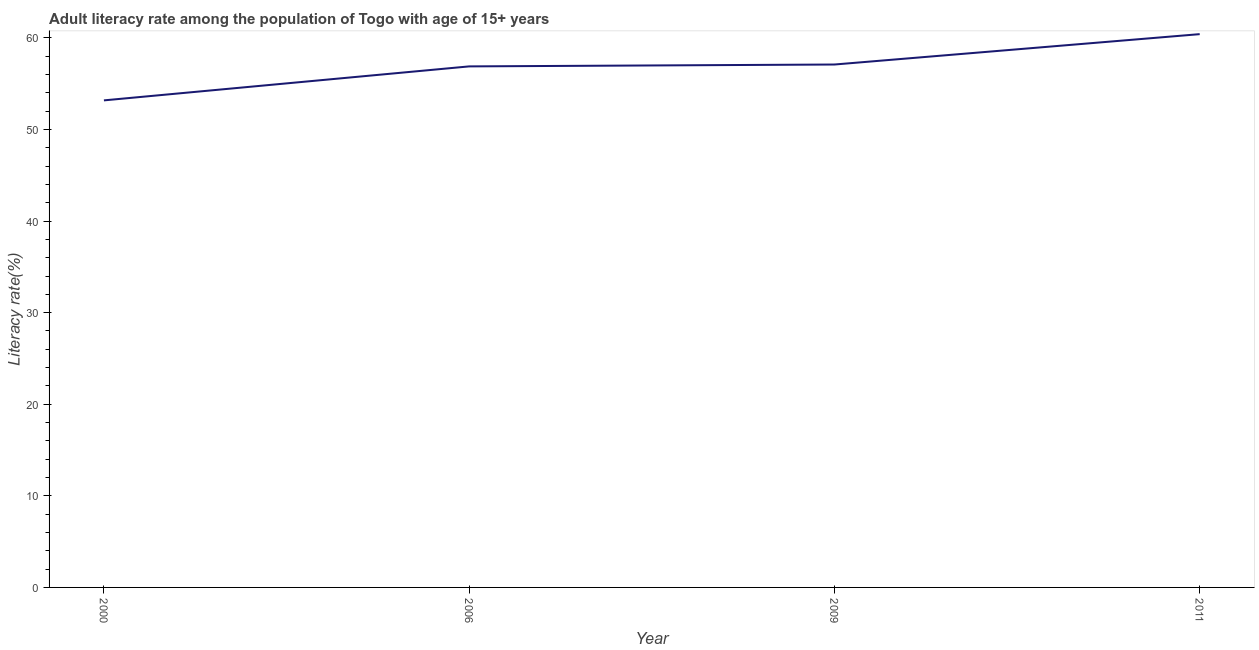What is the adult literacy rate in 2000?
Give a very brief answer. 53.18. Across all years, what is the maximum adult literacy rate?
Offer a terse response. 60.41. Across all years, what is the minimum adult literacy rate?
Provide a short and direct response. 53.18. In which year was the adult literacy rate maximum?
Offer a very short reply. 2011. In which year was the adult literacy rate minimum?
Offer a very short reply. 2000. What is the sum of the adult literacy rate?
Provide a succinct answer. 227.57. What is the difference between the adult literacy rate in 2000 and 2009?
Your answer should be compact. -3.92. What is the average adult literacy rate per year?
Your answer should be compact. 56.89. What is the median adult literacy rate?
Give a very brief answer. 56.99. In how many years, is the adult literacy rate greater than 18 %?
Make the answer very short. 4. Do a majority of the years between 2009 and 2000 (inclusive) have adult literacy rate greater than 42 %?
Provide a succinct answer. No. What is the ratio of the adult literacy rate in 2000 to that in 2011?
Keep it short and to the point. 0.88. What is the difference between the highest and the second highest adult literacy rate?
Make the answer very short. 3.32. What is the difference between the highest and the lowest adult literacy rate?
Offer a very short reply. 7.23. In how many years, is the adult literacy rate greater than the average adult literacy rate taken over all years?
Make the answer very short. 2. How many years are there in the graph?
Your answer should be very brief. 4. Are the values on the major ticks of Y-axis written in scientific E-notation?
Provide a succinct answer. No. What is the title of the graph?
Your response must be concise. Adult literacy rate among the population of Togo with age of 15+ years. What is the label or title of the Y-axis?
Provide a short and direct response. Literacy rate(%). What is the Literacy rate(%) of 2000?
Provide a succinct answer. 53.18. What is the Literacy rate(%) of 2006?
Keep it short and to the point. 56.89. What is the Literacy rate(%) in 2009?
Keep it short and to the point. 57.09. What is the Literacy rate(%) in 2011?
Provide a succinct answer. 60.41. What is the difference between the Literacy rate(%) in 2000 and 2006?
Offer a very short reply. -3.71. What is the difference between the Literacy rate(%) in 2000 and 2009?
Ensure brevity in your answer.  -3.92. What is the difference between the Literacy rate(%) in 2000 and 2011?
Your response must be concise. -7.23. What is the difference between the Literacy rate(%) in 2006 and 2009?
Keep it short and to the point. -0.21. What is the difference between the Literacy rate(%) in 2006 and 2011?
Ensure brevity in your answer.  -3.52. What is the difference between the Literacy rate(%) in 2009 and 2011?
Give a very brief answer. -3.32. What is the ratio of the Literacy rate(%) in 2000 to that in 2006?
Give a very brief answer. 0.94. What is the ratio of the Literacy rate(%) in 2000 to that in 2011?
Offer a terse response. 0.88. What is the ratio of the Literacy rate(%) in 2006 to that in 2011?
Ensure brevity in your answer.  0.94. What is the ratio of the Literacy rate(%) in 2009 to that in 2011?
Make the answer very short. 0.94. 